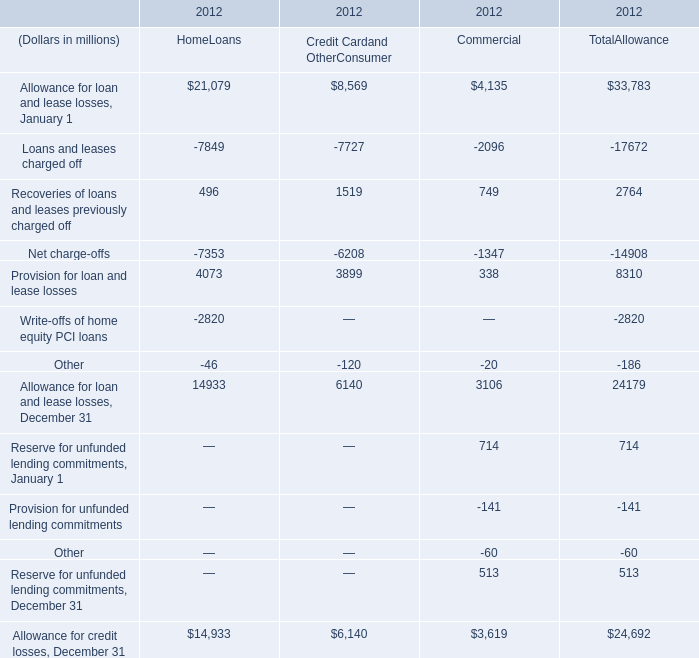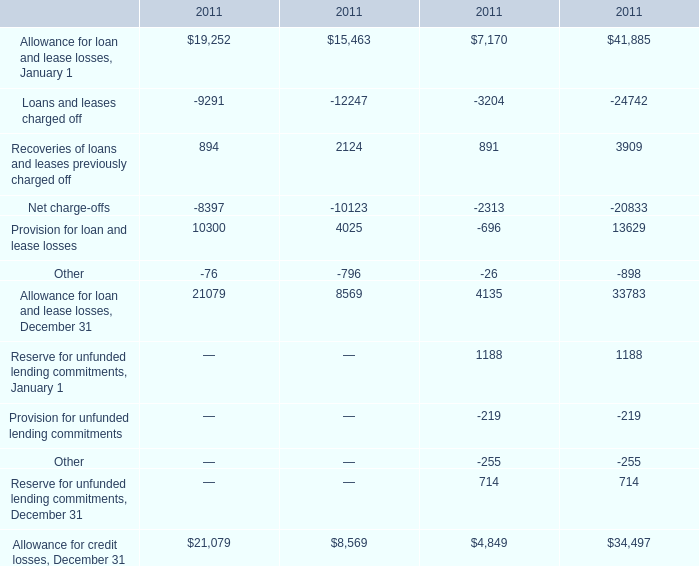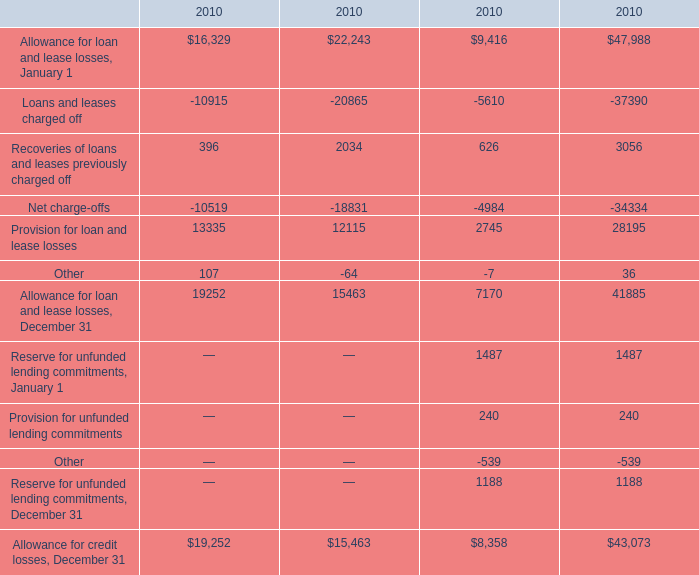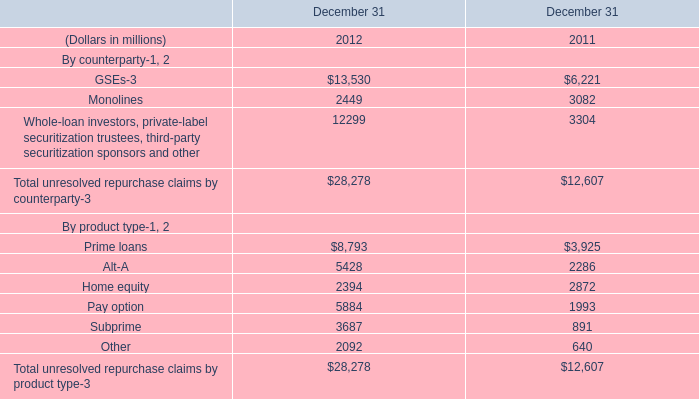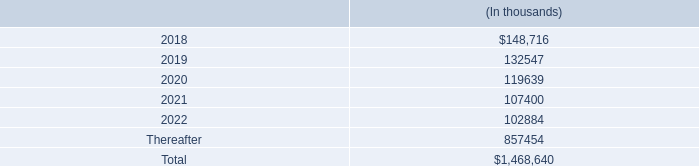what was the average storage costs from 2015 to 2017 in millions 
Computations: ((137.7 + (140.5 + 135.1)) / 3)
Answer: 137.76667. 